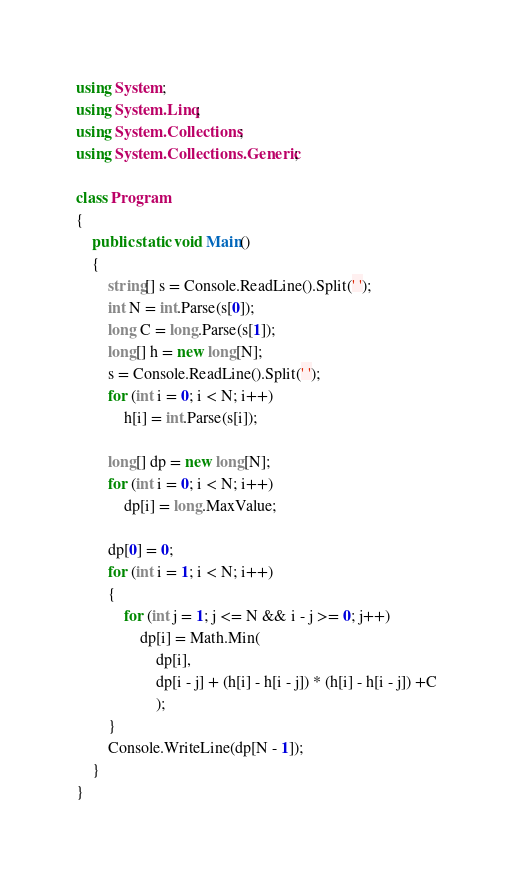Convert code to text. <code><loc_0><loc_0><loc_500><loc_500><_C#_>using System;
using System.Linq;
using System.Collections;
using System.Collections.Generic;

class Program
{
    public static void Main()
    {
        string[] s = Console.ReadLine().Split(' ');
        int N = int.Parse(s[0]);
        long C = long.Parse(s[1]);
        long[] h = new long[N];
        s = Console.ReadLine().Split(' ');
        for (int i = 0; i < N; i++)
            h[i] = int.Parse(s[i]);

        long[] dp = new long[N];
        for (int i = 0; i < N; i++)
            dp[i] = long.MaxValue;

        dp[0] = 0;
        for (int i = 1; i < N; i++)
        {
            for (int j = 1; j <= N && i - j >= 0; j++)
                dp[i] = Math.Min(
                    dp[i],
                    dp[i - j] + (h[i] - h[i - j]) * (h[i] - h[i - j]) +C
                    );
        }
        Console.WriteLine(dp[N - 1]);
    }
}</code> 